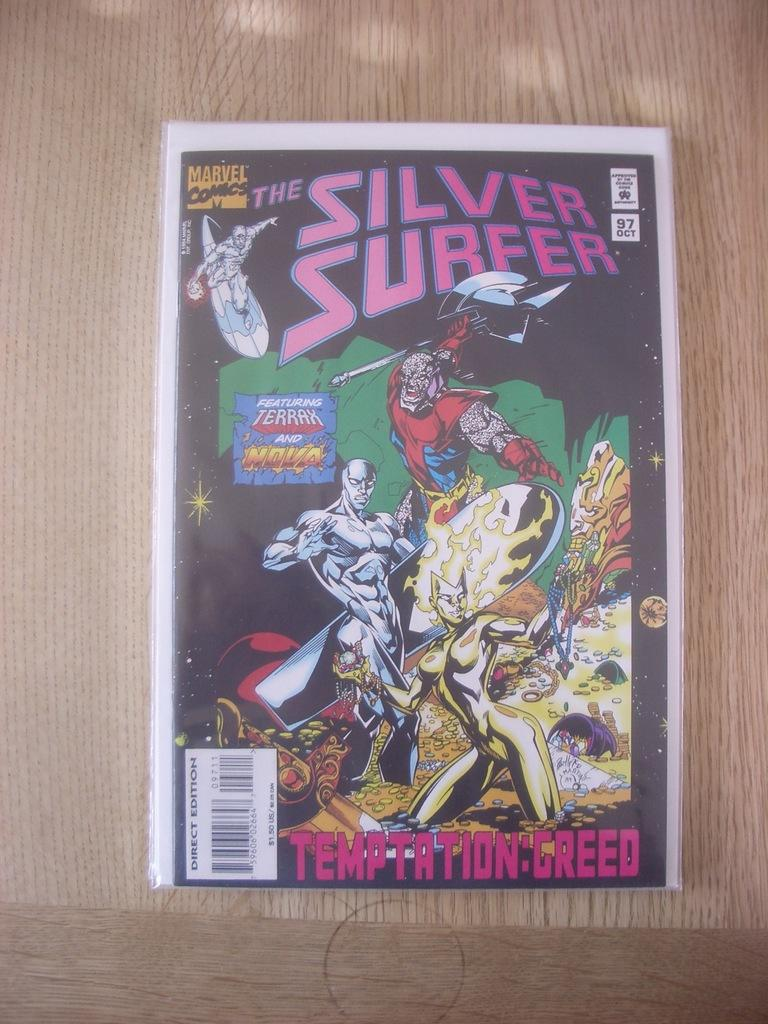<image>
Summarize the visual content of the image. The brand new Marvel comic Silver Surfer has been released. 